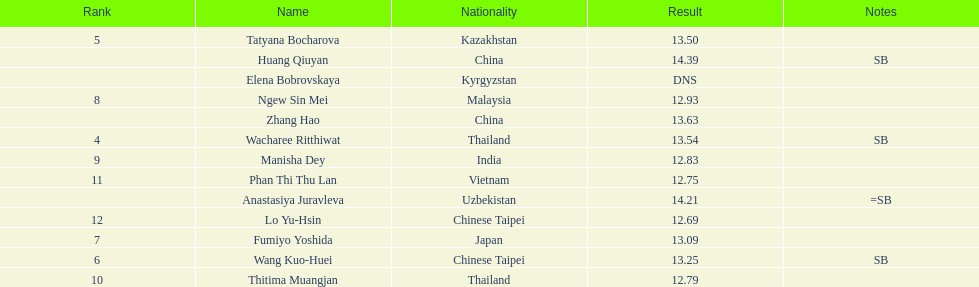How many competitors had less than 13.00 points? 6. 